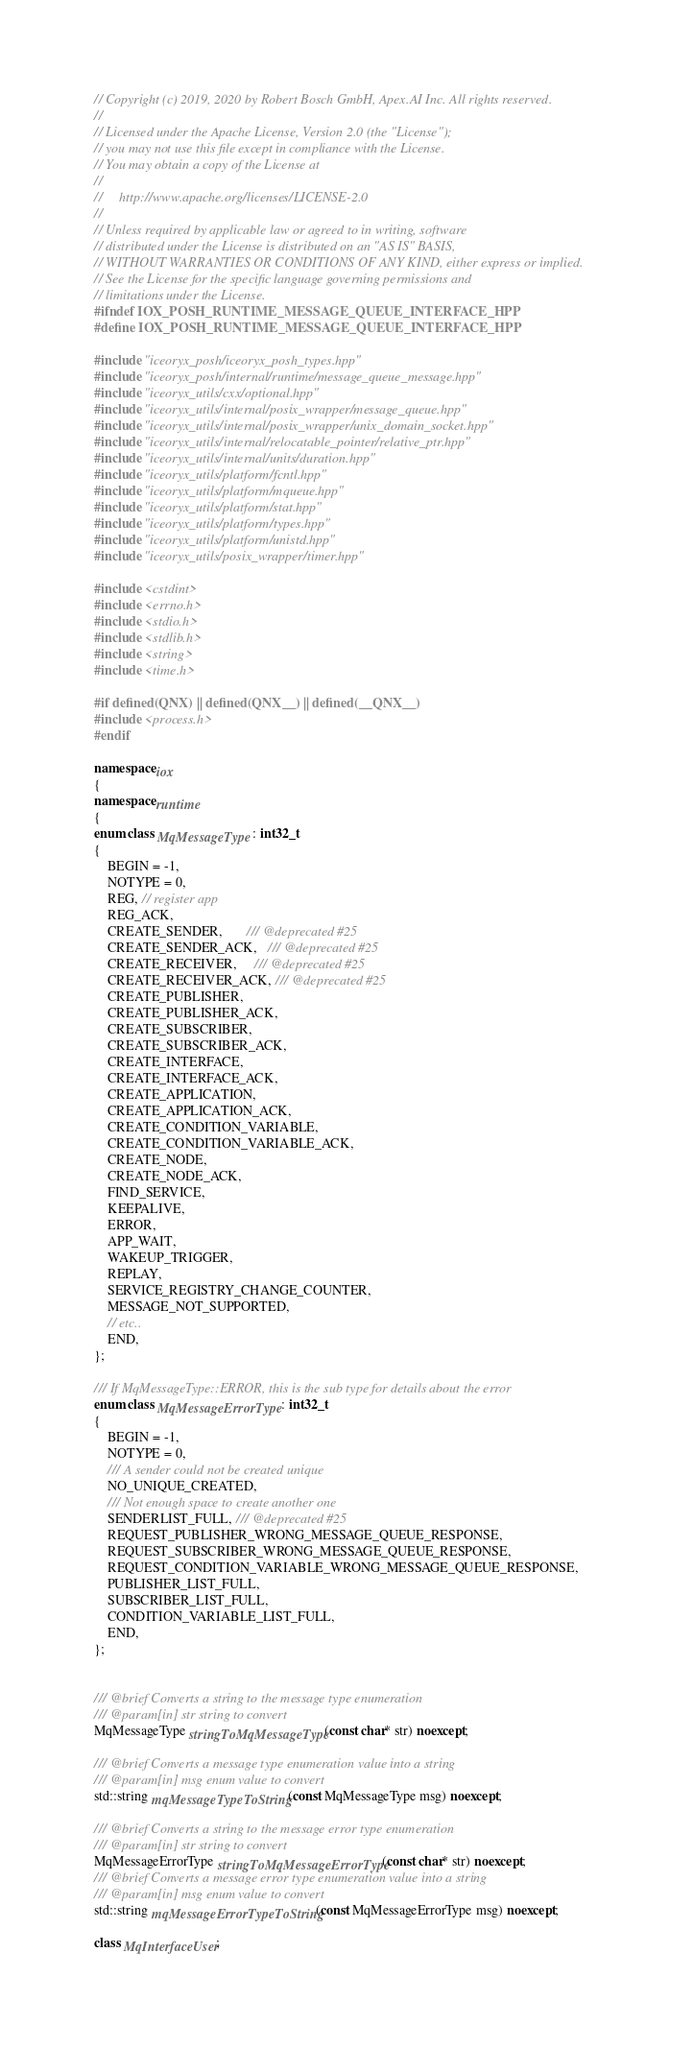<code> <loc_0><loc_0><loc_500><loc_500><_C++_>// Copyright (c) 2019, 2020 by Robert Bosch GmbH, Apex.AI Inc. All rights reserved.
//
// Licensed under the Apache License, Version 2.0 (the "License");
// you may not use this file except in compliance with the License.
// You may obtain a copy of the License at
//
//     http://www.apache.org/licenses/LICENSE-2.0
//
// Unless required by applicable law or agreed to in writing, software
// distributed under the License is distributed on an "AS IS" BASIS,
// WITHOUT WARRANTIES OR CONDITIONS OF ANY KIND, either express or implied.
// See the License for the specific language governing permissions and
// limitations under the License.
#ifndef IOX_POSH_RUNTIME_MESSAGE_QUEUE_INTERFACE_HPP
#define IOX_POSH_RUNTIME_MESSAGE_QUEUE_INTERFACE_HPP

#include "iceoryx_posh/iceoryx_posh_types.hpp"
#include "iceoryx_posh/internal/runtime/message_queue_message.hpp"
#include "iceoryx_utils/cxx/optional.hpp"
#include "iceoryx_utils/internal/posix_wrapper/message_queue.hpp"
#include "iceoryx_utils/internal/posix_wrapper/unix_domain_socket.hpp"
#include "iceoryx_utils/internal/relocatable_pointer/relative_ptr.hpp"
#include "iceoryx_utils/internal/units/duration.hpp"
#include "iceoryx_utils/platform/fcntl.hpp"
#include "iceoryx_utils/platform/mqueue.hpp"
#include "iceoryx_utils/platform/stat.hpp"
#include "iceoryx_utils/platform/types.hpp"
#include "iceoryx_utils/platform/unistd.hpp"
#include "iceoryx_utils/posix_wrapper/timer.hpp"

#include <cstdint>
#include <errno.h>
#include <stdio.h>
#include <stdlib.h>
#include <string>
#include <time.h>

#if defined(QNX) || defined(QNX__) || defined(__QNX__)
#include <process.h>
#endif

namespace iox
{
namespace runtime
{
enum class MqMessageType : int32_t
{
    BEGIN = -1,
    NOTYPE = 0,
    REG, // register app
    REG_ACK,
    CREATE_SENDER,       /// @deprecated #25
    CREATE_SENDER_ACK,   /// @deprecated #25
    CREATE_RECEIVER,     /// @deprecated #25
    CREATE_RECEIVER_ACK, /// @deprecated #25
    CREATE_PUBLISHER,
    CREATE_PUBLISHER_ACK,
    CREATE_SUBSCRIBER,
    CREATE_SUBSCRIBER_ACK,
    CREATE_INTERFACE,
    CREATE_INTERFACE_ACK,
    CREATE_APPLICATION,
    CREATE_APPLICATION_ACK,
    CREATE_CONDITION_VARIABLE,
    CREATE_CONDITION_VARIABLE_ACK,
    CREATE_NODE,
    CREATE_NODE_ACK,
    FIND_SERVICE,
    KEEPALIVE,
    ERROR,
    APP_WAIT,
    WAKEUP_TRIGGER,
    REPLAY,
    SERVICE_REGISTRY_CHANGE_COUNTER,
    MESSAGE_NOT_SUPPORTED,
    // etc..
    END,
};

/// If MqMessageType::ERROR, this is the sub type for details about the error
enum class MqMessageErrorType : int32_t
{
    BEGIN = -1,
    NOTYPE = 0,
    /// A sender could not be created unique
    NO_UNIQUE_CREATED,
    /// Not enough space to create another one
    SENDERLIST_FULL, /// @deprecated #25
    REQUEST_PUBLISHER_WRONG_MESSAGE_QUEUE_RESPONSE,
    REQUEST_SUBSCRIBER_WRONG_MESSAGE_QUEUE_RESPONSE,
    REQUEST_CONDITION_VARIABLE_WRONG_MESSAGE_QUEUE_RESPONSE,
    PUBLISHER_LIST_FULL,
    SUBSCRIBER_LIST_FULL,
    CONDITION_VARIABLE_LIST_FULL,
    END,
};


/// @brief Converts a string to the message type enumeration
/// @param[in] str string to convert
MqMessageType stringToMqMessageType(const char* str) noexcept;

/// @brief Converts a message type enumeration value into a string
/// @param[in] msg enum value to convert
std::string mqMessageTypeToString(const MqMessageType msg) noexcept;

/// @brief Converts a string to the message error type enumeration
/// @param[in] str string to convert
MqMessageErrorType stringToMqMessageErrorType(const char* str) noexcept;
/// @brief Converts a message error type enumeration value into a string
/// @param[in] msg enum value to convert
std::string mqMessageErrorTypeToString(const MqMessageErrorType msg) noexcept;

class MqInterfaceUser;</code> 